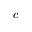Convert formula to latex. <formula><loc_0><loc_0><loc_500><loc_500>c</formula> 